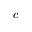Convert formula to latex. <formula><loc_0><loc_0><loc_500><loc_500>c</formula> 